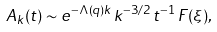<formula> <loc_0><loc_0><loc_500><loc_500>A _ { k } ( t ) \sim e ^ { - \Lambda ( q ) k } \, k ^ { - 3 / 2 } \, t ^ { - 1 } \, F ( \xi ) ,</formula> 